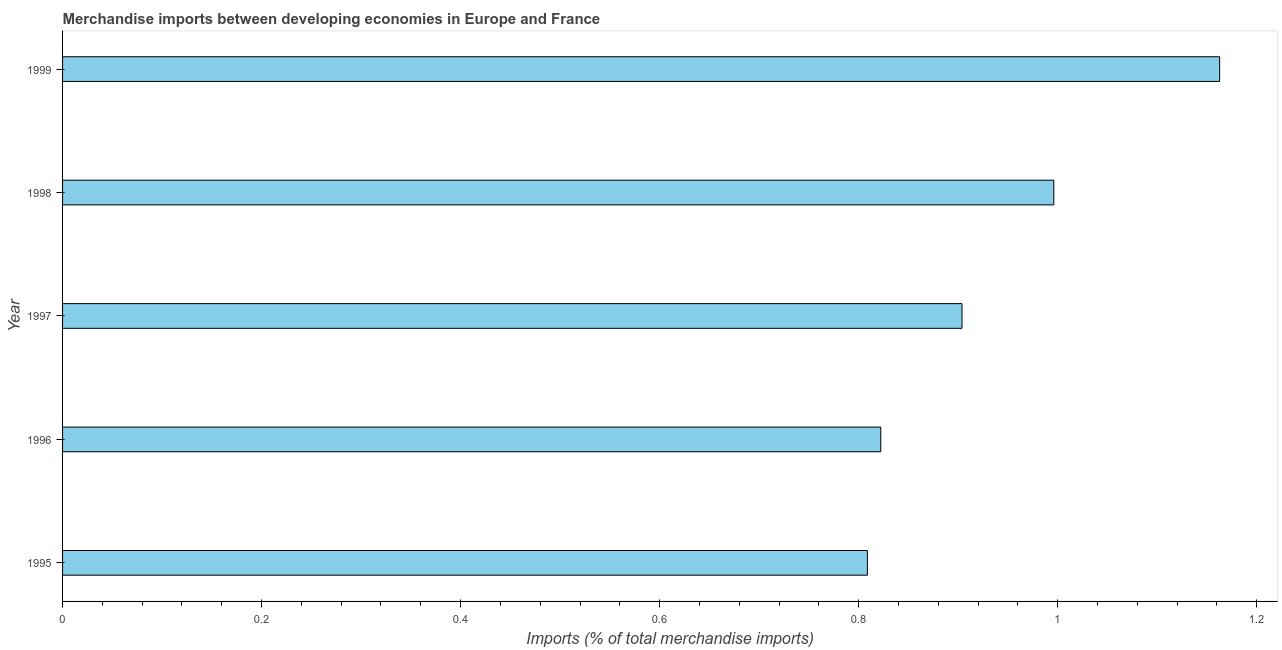Does the graph contain grids?
Make the answer very short. No. What is the title of the graph?
Offer a very short reply. Merchandise imports between developing economies in Europe and France. What is the label or title of the X-axis?
Your response must be concise. Imports (% of total merchandise imports). What is the label or title of the Y-axis?
Offer a terse response. Year. What is the merchandise imports in 1997?
Your answer should be compact. 0.9. Across all years, what is the maximum merchandise imports?
Give a very brief answer. 1.16. Across all years, what is the minimum merchandise imports?
Provide a short and direct response. 0.81. In which year was the merchandise imports maximum?
Keep it short and to the point. 1999. What is the sum of the merchandise imports?
Your answer should be very brief. 4.69. What is the difference between the merchandise imports in 1995 and 1998?
Your answer should be very brief. -0.19. What is the average merchandise imports per year?
Keep it short and to the point. 0.94. What is the median merchandise imports?
Your answer should be very brief. 0.9. What is the ratio of the merchandise imports in 1995 to that in 1997?
Make the answer very short. 0.9. Is the difference between the merchandise imports in 1997 and 1999 greater than the difference between any two years?
Give a very brief answer. No. What is the difference between the highest and the second highest merchandise imports?
Ensure brevity in your answer.  0.17. How many bars are there?
Your answer should be compact. 5. Are all the bars in the graph horizontal?
Ensure brevity in your answer.  Yes. How many years are there in the graph?
Keep it short and to the point. 5. What is the Imports (% of total merchandise imports) of 1995?
Offer a very short reply. 0.81. What is the Imports (% of total merchandise imports) in 1996?
Give a very brief answer. 0.82. What is the Imports (% of total merchandise imports) of 1997?
Offer a terse response. 0.9. What is the Imports (% of total merchandise imports) of 1998?
Give a very brief answer. 1. What is the Imports (% of total merchandise imports) in 1999?
Provide a succinct answer. 1.16. What is the difference between the Imports (% of total merchandise imports) in 1995 and 1996?
Your answer should be compact. -0.01. What is the difference between the Imports (% of total merchandise imports) in 1995 and 1997?
Your response must be concise. -0.1. What is the difference between the Imports (% of total merchandise imports) in 1995 and 1998?
Your response must be concise. -0.19. What is the difference between the Imports (% of total merchandise imports) in 1995 and 1999?
Your answer should be very brief. -0.35. What is the difference between the Imports (% of total merchandise imports) in 1996 and 1997?
Give a very brief answer. -0.08. What is the difference between the Imports (% of total merchandise imports) in 1996 and 1998?
Offer a terse response. -0.17. What is the difference between the Imports (% of total merchandise imports) in 1996 and 1999?
Provide a succinct answer. -0.34. What is the difference between the Imports (% of total merchandise imports) in 1997 and 1998?
Your answer should be compact. -0.09. What is the difference between the Imports (% of total merchandise imports) in 1997 and 1999?
Offer a terse response. -0.26. What is the difference between the Imports (% of total merchandise imports) in 1998 and 1999?
Provide a succinct answer. -0.17. What is the ratio of the Imports (% of total merchandise imports) in 1995 to that in 1996?
Offer a very short reply. 0.98. What is the ratio of the Imports (% of total merchandise imports) in 1995 to that in 1997?
Keep it short and to the point. 0.9. What is the ratio of the Imports (% of total merchandise imports) in 1995 to that in 1998?
Give a very brief answer. 0.81. What is the ratio of the Imports (% of total merchandise imports) in 1995 to that in 1999?
Your response must be concise. 0.7. What is the ratio of the Imports (% of total merchandise imports) in 1996 to that in 1997?
Keep it short and to the point. 0.91. What is the ratio of the Imports (% of total merchandise imports) in 1996 to that in 1998?
Keep it short and to the point. 0.82. What is the ratio of the Imports (% of total merchandise imports) in 1996 to that in 1999?
Provide a short and direct response. 0.71. What is the ratio of the Imports (% of total merchandise imports) in 1997 to that in 1998?
Offer a terse response. 0.91. What is the ratio of the Imports (% of total merchandise imports) in 1997 to that in 1999?
Give a very brief answer. 0.78. What is the ratio of the Imports (% of total merchandise imports) in 1998 to that in 1999?
Offer a very short reply. 0.86. 